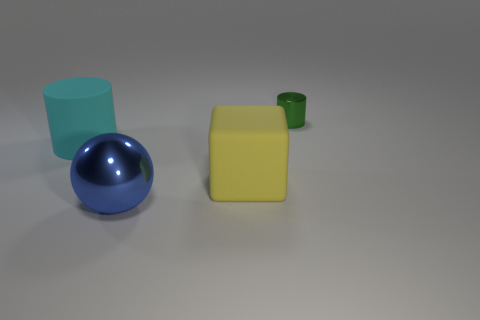Subtract all green cylinders. Subtract all green spheres. How many cylinders are left? 1 Add 2 big yellow matte blocks. How many objects exist? 6 Subtract all blocks. How many objects are left? 3 Subtract all small purple cubes. Subtract all green objects. How many objects are left? 3 Add 4 big objects. How many big objects are left? 7 Add 4 purple metal cylinders. How many purple metal cylinders exist? 4 Subtract 0 yellow cylinders. How many objects are left? 4 